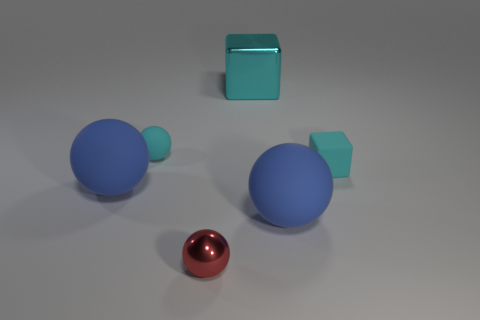Subtract all red balls. How many balls are left? 3 Subtract all blue cubes. How many blue spheres are left? 2 Subtract all cyan spheres. How many spheres are left? 3 Subtract 2 spheres. How many spheres are left? 2 Add 3 big red cylinders. How many objects exist? 9 Subtract all blocks. How many objects are left? 4 Add 6 tiny red metal spheres. How many tiny red metal spheres are left? 7 Add 3 green objects. How many green objects exist? 3 Subtract 1 cyan spheres. How many objects are left? 5 Subtract all green spheres. Subtract all blue blocks. How many spheres are left? 4 